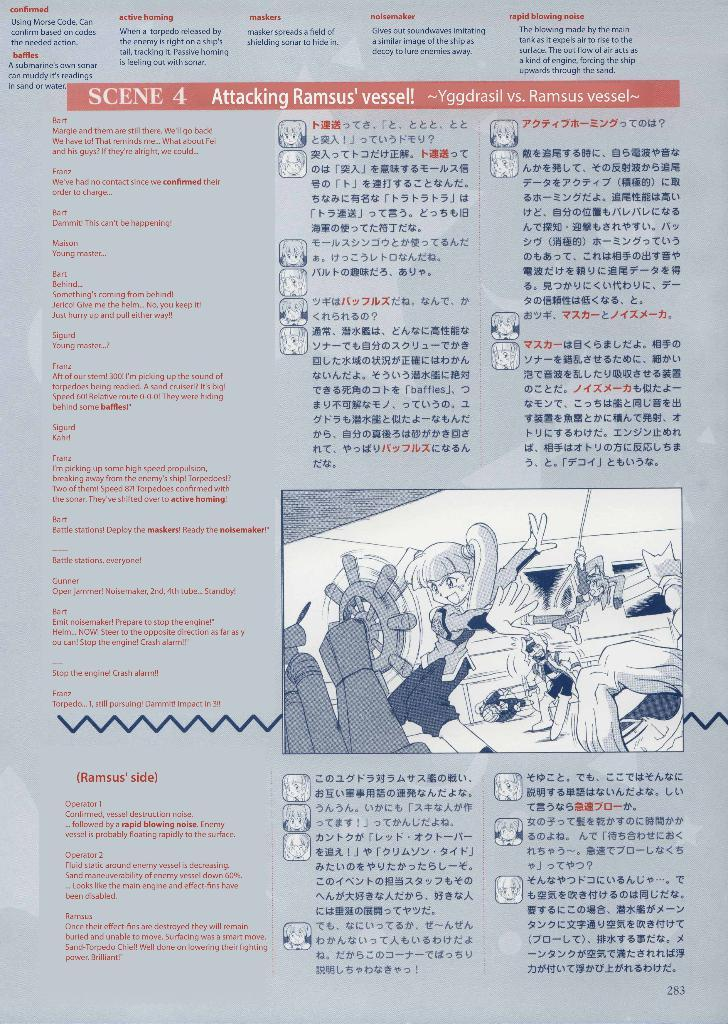<image>
Give a short and clear explanation of the subsequent image. A page of writing in both English and a foreign language describing Scene 4, Attacking Ramsus' vessel! 